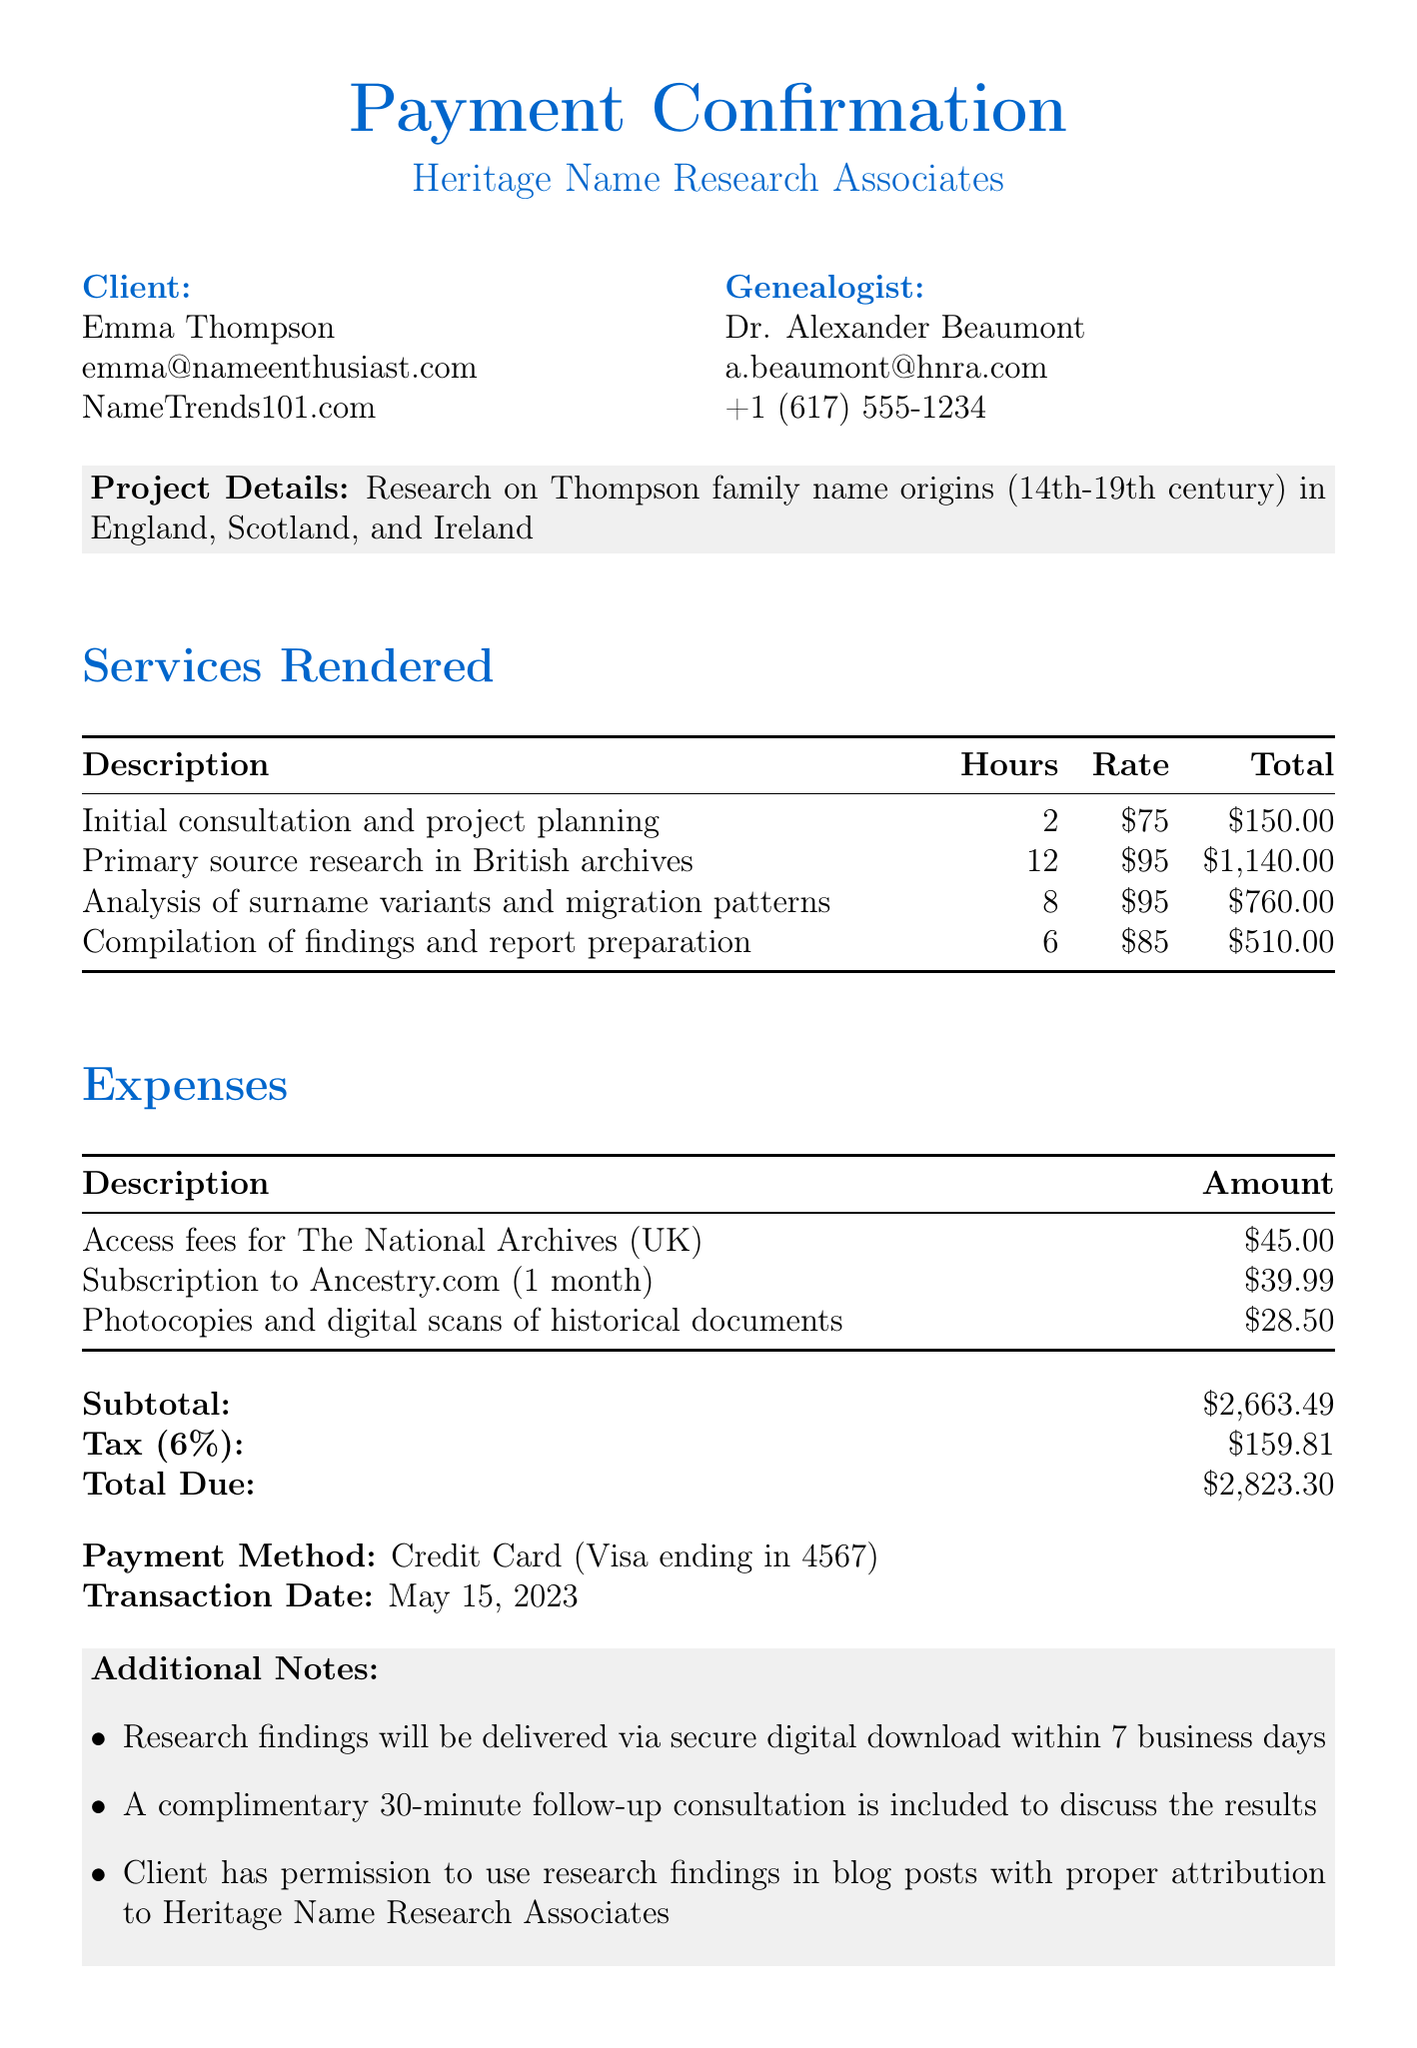What is the name of the client? The document explicitly states the client's name as Emma Thompson.
Answer: Emma Thompson Who is the genealogist? The document lists the genealogist as Dr. Alexander Beaumont.
Answer: Dr. Alexander Beaumont What are the origin regions for the Thompson family name? The document mentions that the origin regions are England, Scotland, and Ireland.
Answer: England, Scotland, Ireland How many hours were spent on primary source research in British archives? The document indicates 12 hours were allocated for primary source research.
Answer: 12 What is the subtotal amount before tax? The subtotal is explicitly stated as $2663.49 in the document.
Answer: $2663.49 What is the total amount due including tax? The total due includes the subtotal and tax and is listed as $2823.30.
Answer: $2823.30 What expense is related to The National Archives? The document contains an entry under expenses for access fees to The National Archives, which is $45.00.
Answer: Access fees for The National Archives (UK) How long will it take to receive the research findings? The document notes that findings will be delivered within 7 business days.
Answer: 7 business days Is a follow-up consultation included? According to the document, a complimentary follow-up consultation is included.
Answer: Yes 